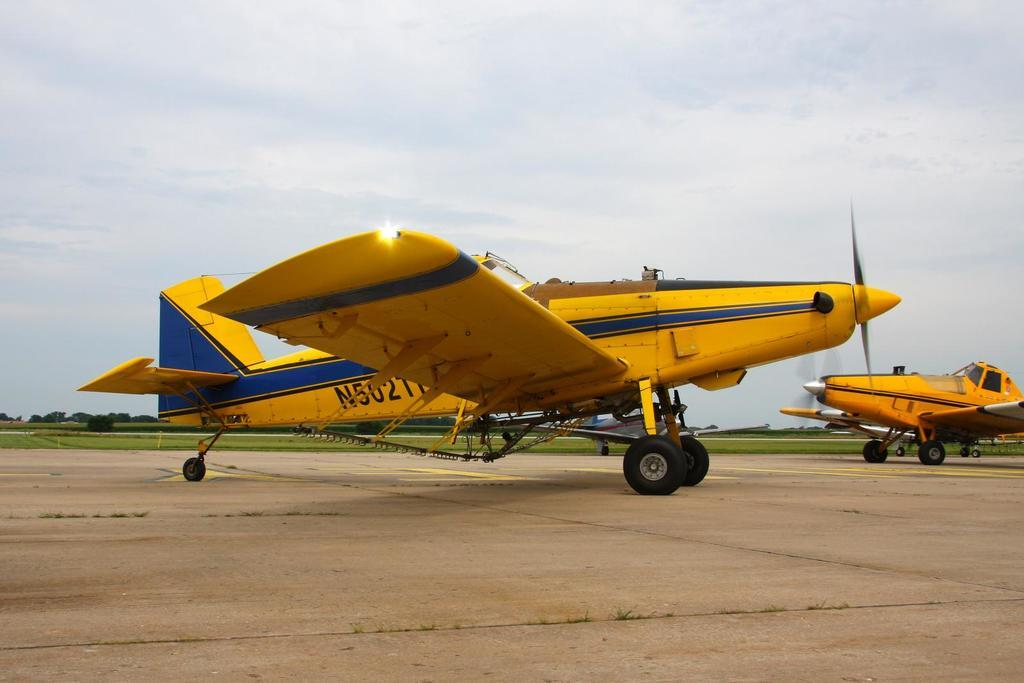<image>
Render a clear and concise summary of the photo. A yellow plane with N502 printed on its side. 